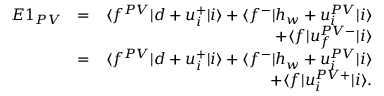Convert formula to latex. <formula><loc_0><loc_0><loc_500><loc_500>\begin{array} { r l r } { E 1 _ { P V } } & { = } & { \langle f ^ { P V } | d + u _ { i } ^ { + } | i \rangle + \langle f ^ { - } | h _ { w } + u _ { i } ^ { P V } | i \rangle } \\ & { + \langle f | u _ { f } ^ { P V - } | i \rangle } \\ & { = } & { \langle f ^ { P V } | d + u _ { i } ^ { + } | i \rangle + \langle f ^ { - } | h _ { w } + u _ { i } ^ { P V } | i \rangle } \\ & { + \langle f | u _ { i } ^ { P V + } | i \rangle . } \end{array}</formula> 